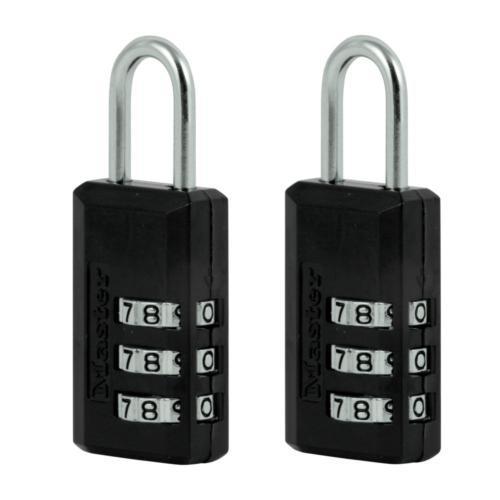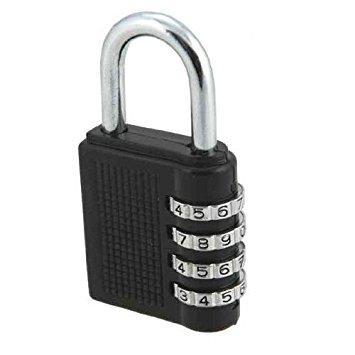The first image is the image on the left, the second image is the image on the right. Assess this claim about the two images: "All of the locks have black bodies with a metal ring.". Correct or not? Answer yes or no. Yes. The first image is the image on the left, the second image is the image on the right. Given the left and right images, does the statement "All combination locks have black bodies with silver lock loops at the top, and black numbers on sliding silver number belts." hold true? Answer yes or no. Yes. 